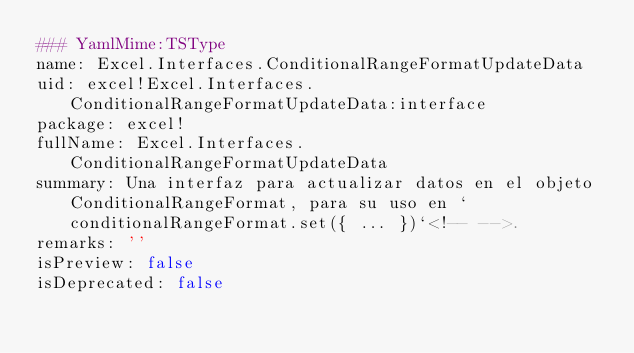<code> <loc_0><loc_0><loc_500><loc_500><_YAML_>### YamlMime:TSType
name: Excel.Interfaces.ConditionalRangeFormatUpdateData
uid: excel!Excel.Interfaces.ConditionalRangeFormatUpdateData:interface
package: excel!
fullName: Excel.Interfaces.ConditionalRangeFormatUpdateData
summary: Una interfaz para actualizar datos en el objeto ConditionalRangeFormat, para su uso en `conditionalRangeFormat.set({ ... })`<!-- -->.
remarks: ''
isPreview: false
isDeprecated: false</code> 